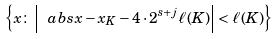<formula> <loc_0><loc_0><loc_500><loc_500>\left \{ x \colon \left | \ a b s { x - x _ { K } } - 4 \cdot 2 ^ { s + j } \ell ( K ) \right | < \ell ( K ) \right \}</formula> 